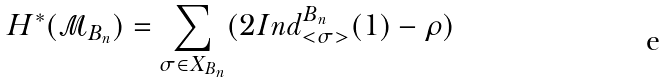Convert formula to latex. <formula><loc_0><loc_0><loc_500><loc_500>H ^ { * } ( \mathcal { M } _ { B _ { n } } ) = \sum _ { \sigma \in X _ { B _ { n } } } ( 2 I n d _ { < \sigma > } ^ { B _ { n } } ( 1 ) - \rho )</formula> 